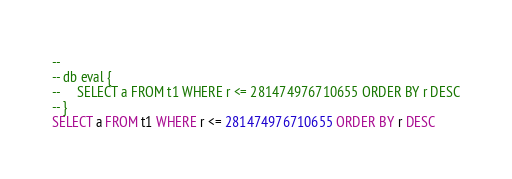<code> <loc_0><loc_0><loc_500><loc_500><_SQL_>-- 
-- db eval {
--     SELECT a FROM t1 WHERE r <= 281474976710655 ORDER BY r DESC
-- }
SELECT a FROM t1 WHERE r <= 281474976710655 ORDER BY r DESC</code> 